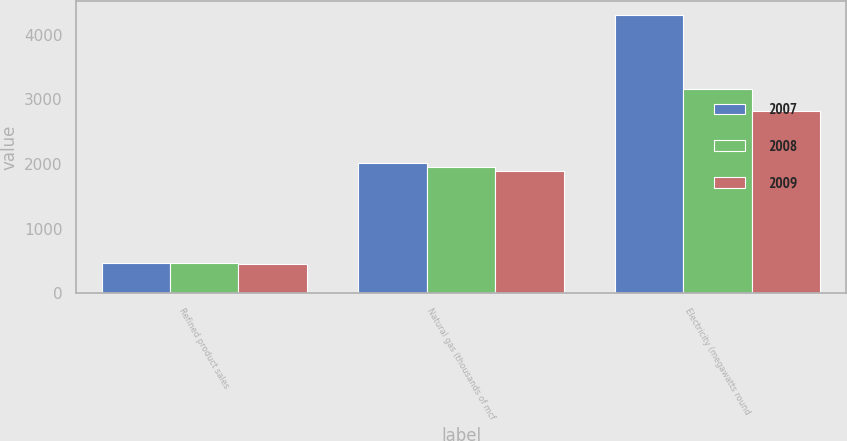Convert chart. <chart><loc_0><loc_0><loc_500><loc_500><stacked_bar_chart><ecel><fcel>Refined product sales<fcel>Natural gas (thousands of mcf<fcel>Electricity (megawatts round<nl><fcel>2007<fcel>473<fcel>2010<fcel>4306<nl><fcel>2008<fcel>472<fcel>1955<fcel>3152<nl><fcel>2009<fcel>451<fcel>1890<fcel>2821<nl></chart> 